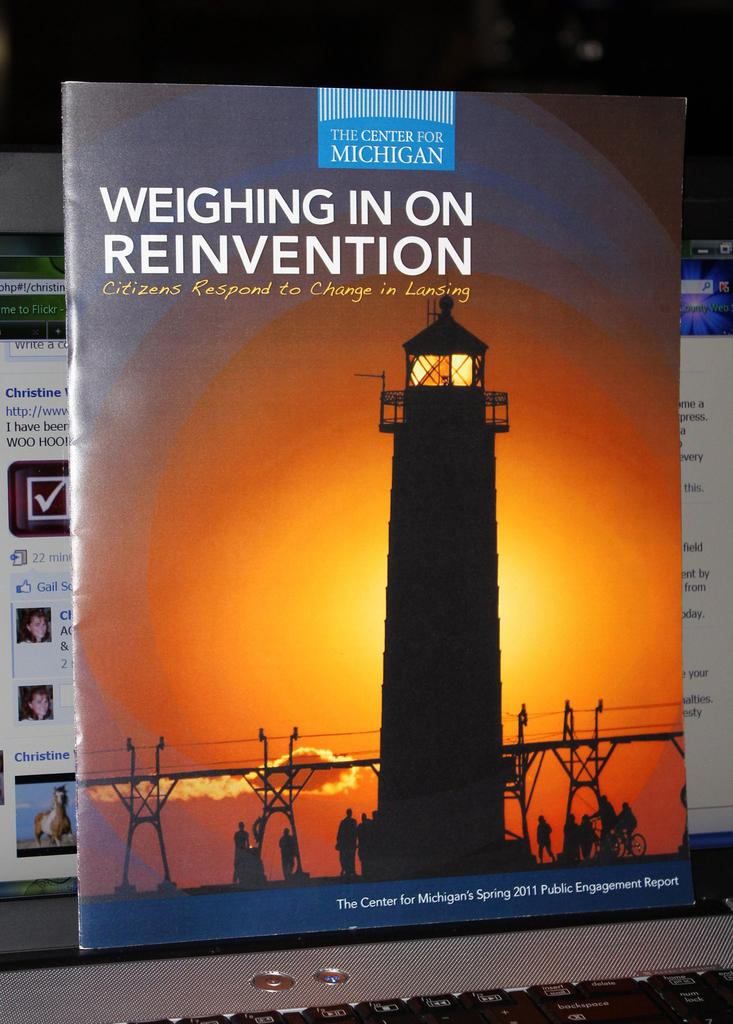Provide a one-sentence caption for the provided image. The Center for Michigan is shown on this advert flyer. 